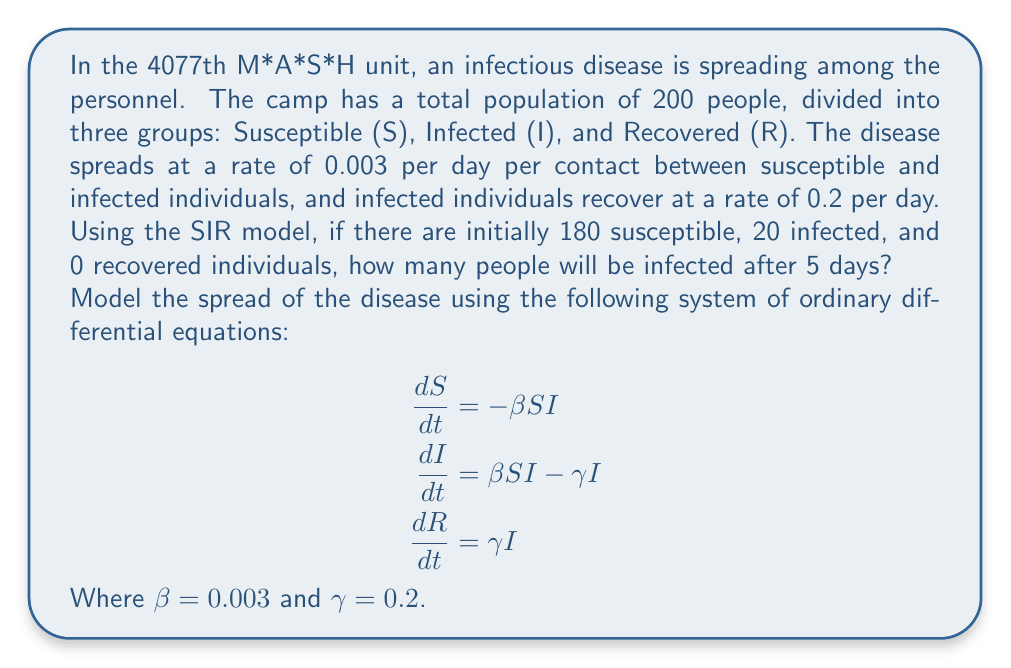What is the answer to this math problem? To solve this problem, we need to use numerical methods to approximate the solution of the SIR model. We'll use the Euler method with a small time step to estimate the number of infected individuals after 5 days.

Step 1: Set up the initial conditions and parameters
$S_0 = 180$, $I_0 = 20$, $R_0 = 0$
$\beta = 0.003$, $\gamma = 0.2$
$t = 5$ days
Let's use a time step of $\Delta t = 0.1$ days

Step 2: Implement the Euler method
For each time step, we'll update S, I, and R using the following equations:

$$\begin{aligned}
S_{n+1} &= S_n + \Delta t \cdot (-\beta S_n I_n) \\
I_{n+1} &= I_n + \Delta t \cdot (\beta S_n I_n - \gamma I_n) \\
R_{n+1} &= R_n + \Delta t \cdot (\gamma I_n)
\end{aligned}$$

Step 3: Iterate through the time steps
We'll perform 50 iterations to cover the 5-day period.

Here's a Python code snippet to perform the calculations:

```python
import numpy as np

S, I, R = 180, 20, 0
beta, gamma = 0.003, 0.2
dt = 0.1
t = np.arange(0, 5+dt, dt)

for _ in range(len(t)-1):
    dSdt = -beta * S * I
    dIdt = beta * S * I - gamma * I
    dRdt = gamma * I
    
    S += dSdt * dt
    I += dIdt * dt
    R += dRdt * dt

print(f"After 5 days, I = {I:.2f}")
```

Step 4: Interpret the results
Running this code gives us the result that after 5 days, there will be approximately 39.37 infected individuals in the camp.
Answer: 39 infected individuals (rounded to the nearest whole number) 